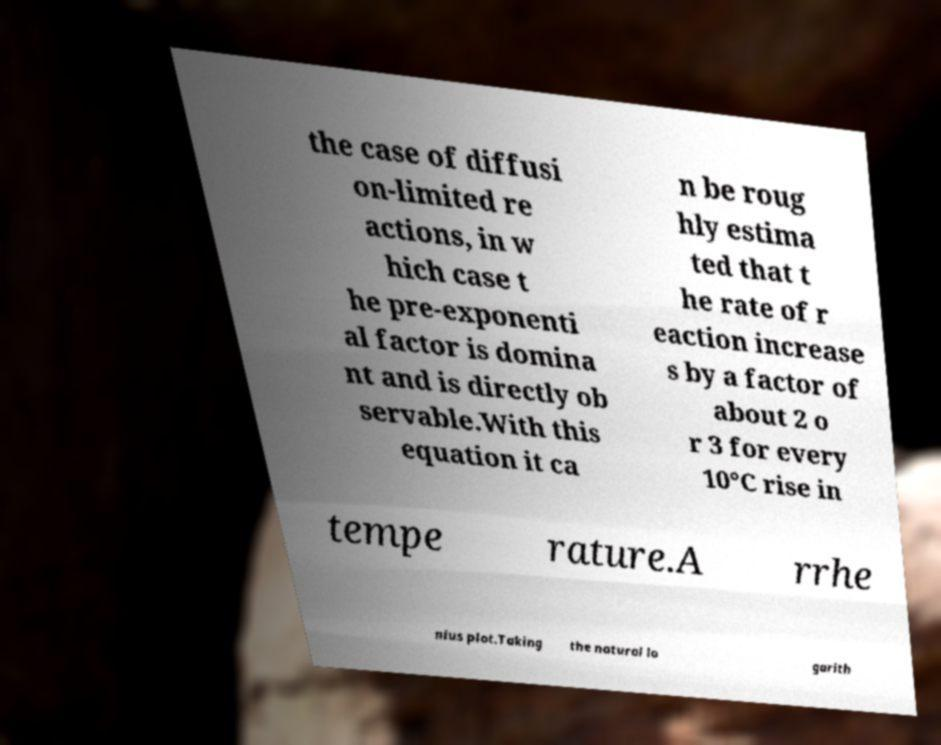Can you accurately transcribe the text from the provided image for me? the case of diffusi on-limited re actions, in w hich case t he pre-exponenti al factor is domina nt and is directly ob servable.With this equation it ca n be roug hly estima ted that t he rate of r eaction increase s by a factor of about 2 o r 3 for every 10°C rise in tempe rature.A rrhe nius plot.Taking the natural lo garith 